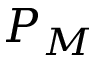<formula> <loc_0><loc_0><loc_500><loc_500>P _ { M }</formula> 